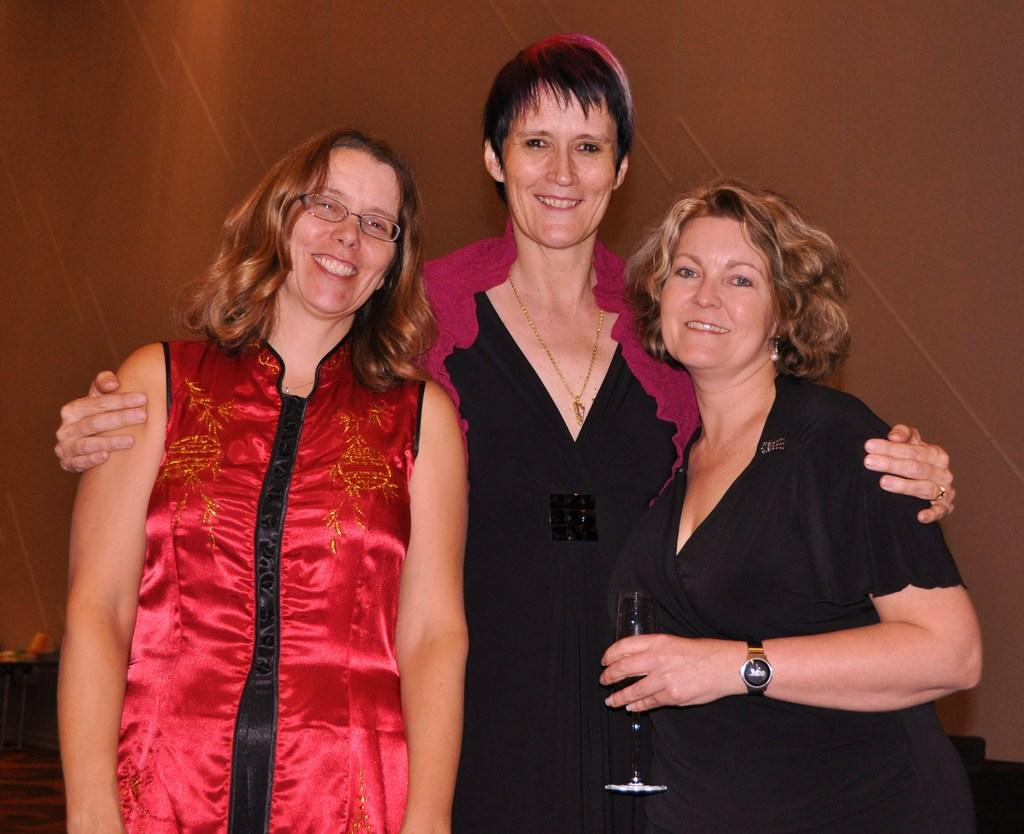What are the women in the image doing? The women in the image are standing and smiling. Can you describe the woman on the right side of the image? The woman on the right side of the image is holding a glass. What can be seen in the background of the image? There is a wall visible in the background of the image. Is there a fire visible in the image? No, there is no fire present in the image. What type of party is being held in the image? There is no indication of a party in the image; it simply shows women standing and smiling. 